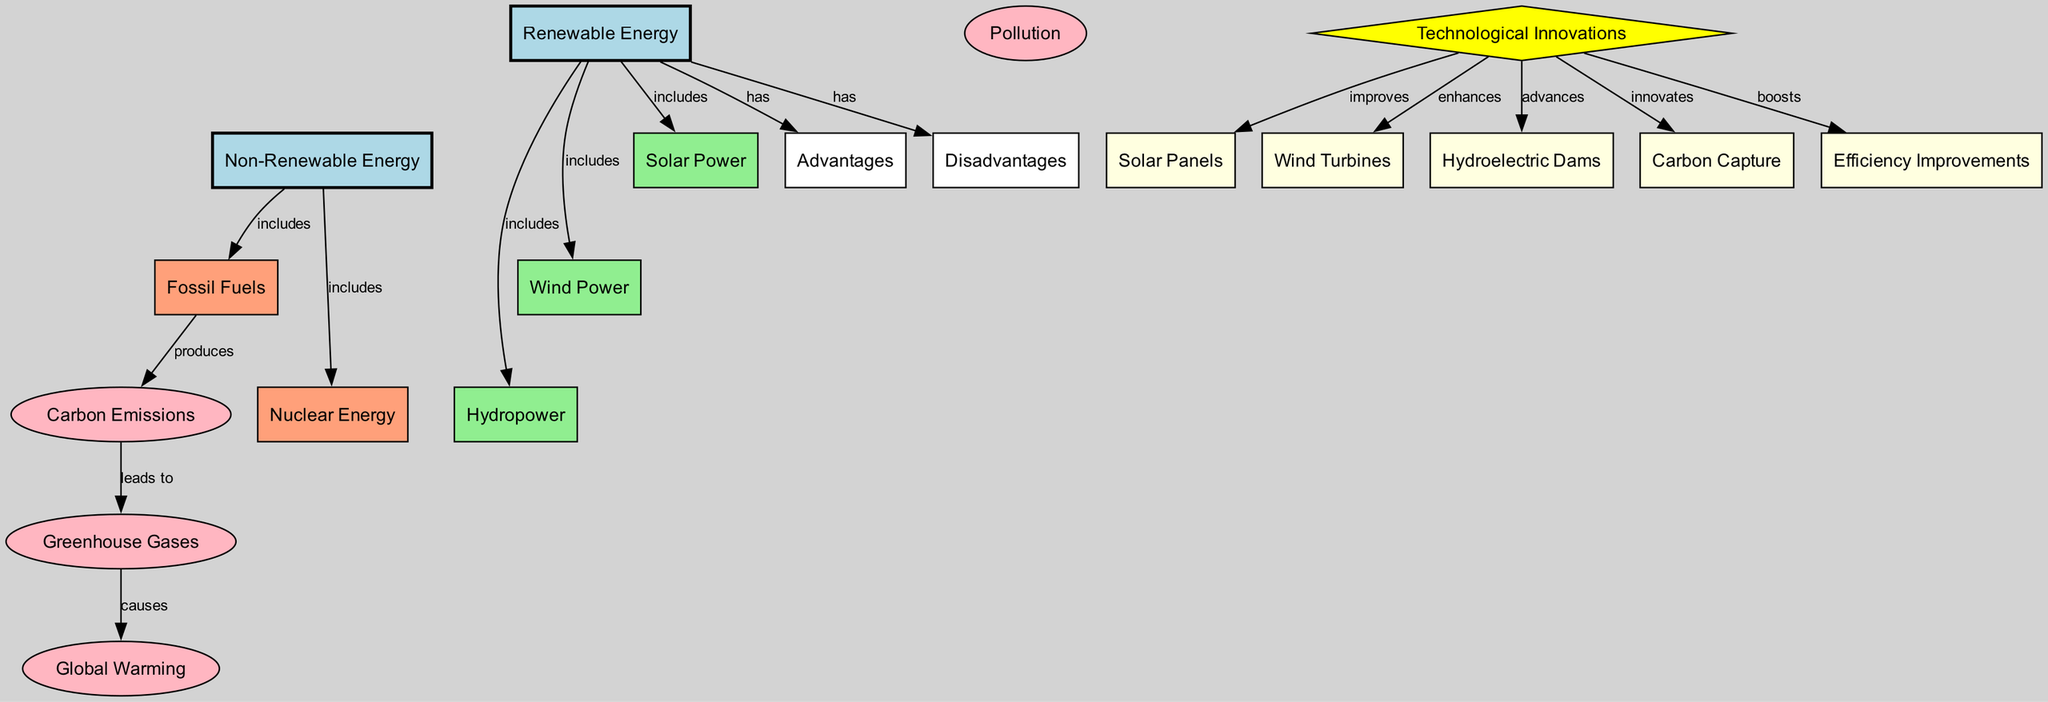What are the three types of renewable energy included in the diagram? The diagram lists three nodes under "Renewable Energy": Solar Power, Wind Power, and Hydropower. There are connecting edges from the "Renewable Energy" node to each of these three nodes, indicating that they are included as types of renewable energy.
Answer: Solar Power, Wind Power, Hydropower Which non-renewable energy source produces carbon emissions? The node "Fossil Fuels" is linked to "Carbon Emissions" with a "produces" relationship. Therefore, Fossil Fuels are the source of carbon emissions in the diagram.
Answer: Fossil Fuels How many advantages and disadvantages does renewable energy have? The diagram shows one node for "Advantages" and one node for "Disadvantages" connected to "Renewable Energy". This indicates that there is one of each.
Answer: 1 advantage and 1 disadvantage What leads to global warming in the diagram? The diagram shows a sequence of nodes: Carbon Emissions leads to Greenhouse Gases, which in turn causes Global Warming. Following this flow, we can deduce that Carbon Emissions are the primary lead to Global Warming.
Answer: Carbon Emissions What innovations improve solar power according to the diagram? The "Technological Innovations" node is linked to "Solar Panels", which indicates that advancements or improvements in technology directly enhance Solar Power. The edge is labeled "improves".
Answer: Solar Panels What color represents renewable energy in the diagram? Renewable Energy nodes are colored light blue, as indicated by the style definitions in the diagram creation code. Therefore, any node representing Renewable Energy will be in this color.
Answer: Light blue What causes greenhouse gases according to the diagram? The edge between "Carbon Emissions" and "Greenhouse Gases" indicates that Carbon Emissions lead to the production of Greenhouse Gases. Thus, Carbon Emissions are the cause of Greenhouse Gases in this context.
Answer: Carbon Emissions Which external environmental concern is linked to fossil fuels? The node "Pollution" is associated with "Fossil Fuels" through an implicit relationship, suggesting that they are linked as both are part of the environmental impact resulting from energy consumption. However, the diagram does not specify edges connected here directly.
Answer: Pollution 